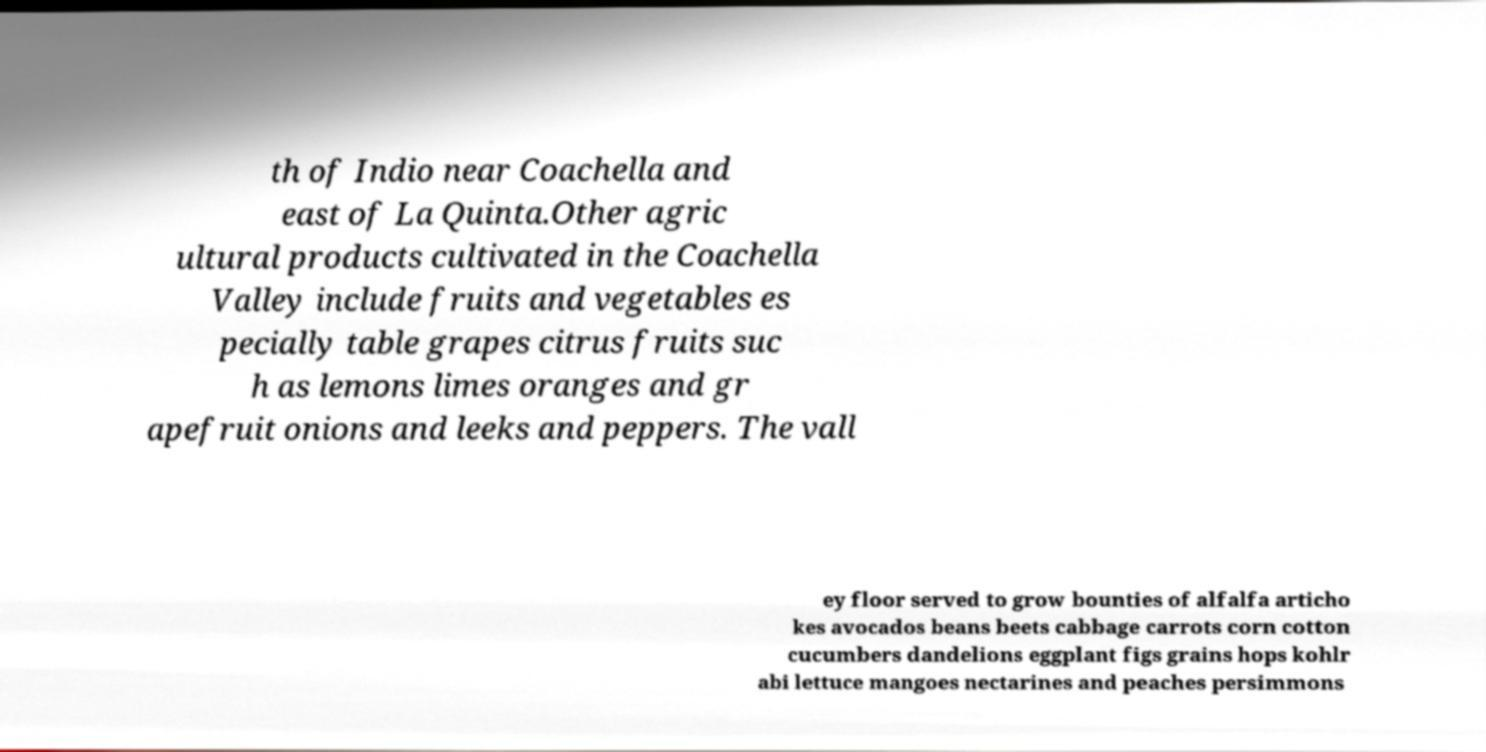There's text embedded in this image that I need extracted. Can you transcribe it verbatim? th of Indio near Coachella and east of La Quinta.Other agric ultural products cultivated in the Coachella Valley include fruits and vegetables es pecially table grapes citrus fruits suc h as lemons limes oranges and gr apefruit onions and leeks and peppers. The vall ey floor served to grow bounties of alfalfa articho kes avocados beans beets cabbage carrots corn cotton cucumbers dandelions eggplant figs grains hops kohlr abi lettuce mangoes nectarines and peaches persimmons 